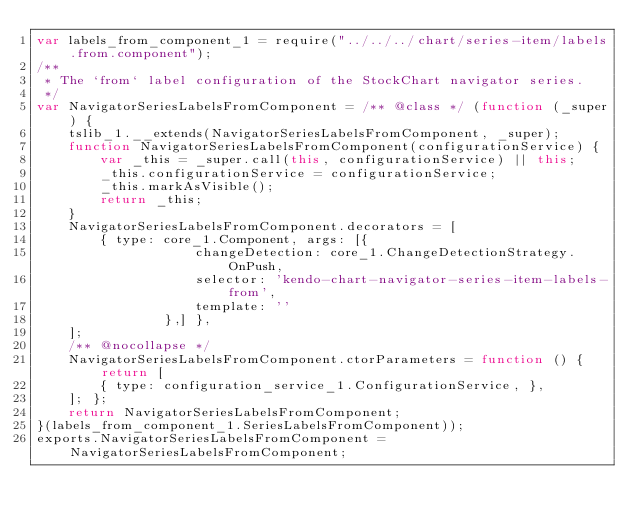Convert code to text. <code><loc_0><loc_0><loc_500><loc_500><_JavaScript_>var labels_from_component_1 = require("../../../chart/series-item/labels.from.component");
/**
 * The `from` label configuration of the StockChart navigator series.
 */
var NavigatorSeriesLabelsFromComponent = /** @class */ (function (_super) {
    tslib_1.__extends(NavigatorSeriesLabelsFromComponent, _super);
    function NavigatorSeriesLabelsFromComponent(configurationService) {
        var _this = _super.call(this, configurationService) || this;
        _this.configurationService = configurationService;
        _this.markAsVisible();
        return _this;
    }
    NavigatorSeriesLabelsFromComponent.decorators = [
        { type: core_1.Component, args: [{
                    changeDetection: core_1.ChangeDetectionStrategy.OnPush,
                    selector: 'kendo-chart-navigator-series-item-labels-from',
                    template: ''
                },] },
    ];
    /** @nocollapse */
    NavigatorSeriesLabelsFromComponent.ctorParameters = function () { return [
        { type: configuration_service_1.ConfigurationService, },
    ]; };
    return NavigatorSeriesLabelsFromComponent;
}(labels_from_component_1.SeriesLabelsFromComponent));
exports.NavigatorSeriesLabelsFromComponent = NavigatorSeriesLabelsFromComponent;
</code> 